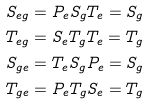Convert formula to latex. <formula><loc_0><loc_0><loc_500><loc_500>S _ { e g } & = P _ { e } S _ { g } T _ { e } = S _ { g } \\ T _ { e g } & = S _ { e } T _ { g } T _ { e } = T _ { g } \\ S _ { g e } & = T _ { e } S _ { g } P _ { e } = S _ { g } \\ T _ { g e } & = P _ { e } T _ { g } S _ { e } = T _ { g } \\</formula> 